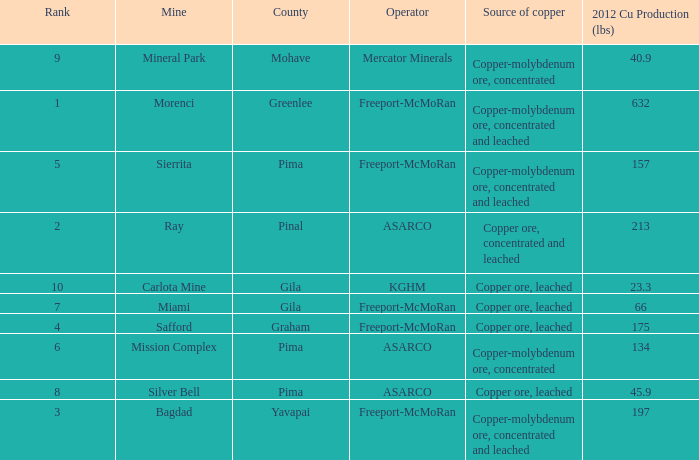Which operator has a rank of 7? Freeport-McMoRan. 